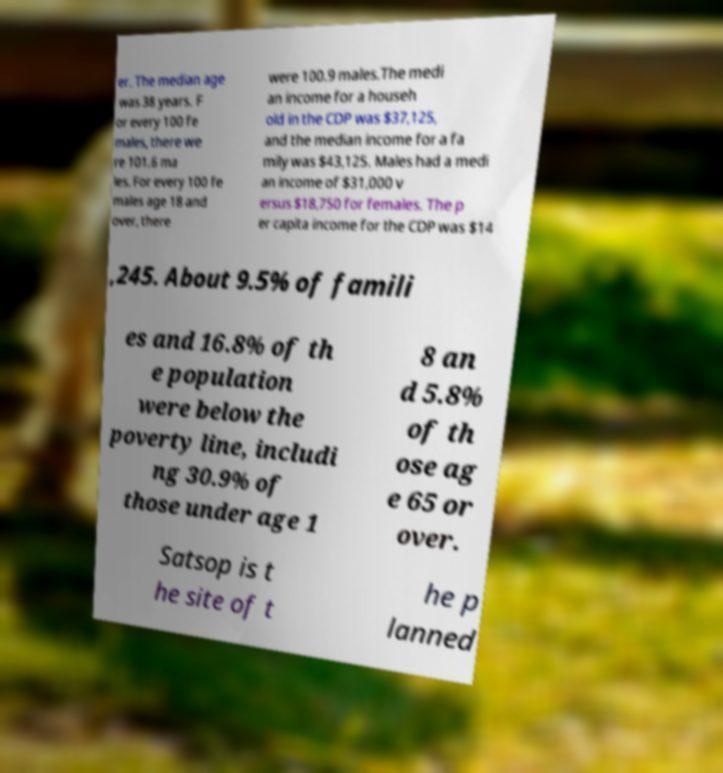Could you extract and type out the text from this image? er. The median age was 38 years. F or every 100 fe males, there we re 101.6 ma les. For every 100 fe males age 18 and over, there were 100.9 males.The medi an income for a househ old in the CDP was $37,125, and the median income for a fa mily was $43,125. Males had a medi an income of $31,000 v ersus $18,750 for females. The p er capita income for the CDP was $14 ,245. About 9.5% of famili es and 16.8% of th e population were below the poverty line, includi ng 30.9% of those under age 1 8 an d 5.8% of th ose ag e 65 or over. Satsop is t he site of t he p lanned 